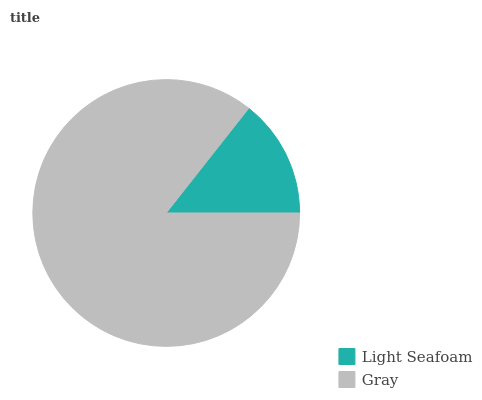Is Light Seafoam the minimum?
Answer yes or no. Yes. Is Gray the maximum?
Answer yes or no. Yes. Is Gray the minimum?
Answer yes or no. No. Is Gray greater than Light Seafoam?
Answer yes or no. Yes. Is Light Seafoam less than Gray?
Answer yes or no. Yes. Is Light Seafoam greater than Gray?
Answer yes or no. No. Is Gray less than Light Seafoam?
Answer yes or no. No. Is Gray the high median?
Answer yes or no. Yes. Is Light Seafoam the low median?
Answer yes or no. Yes. Is Light Seafoam the high median?
Answer yes or no. No. Is Gray the low median?
Answer yes or no. No. 